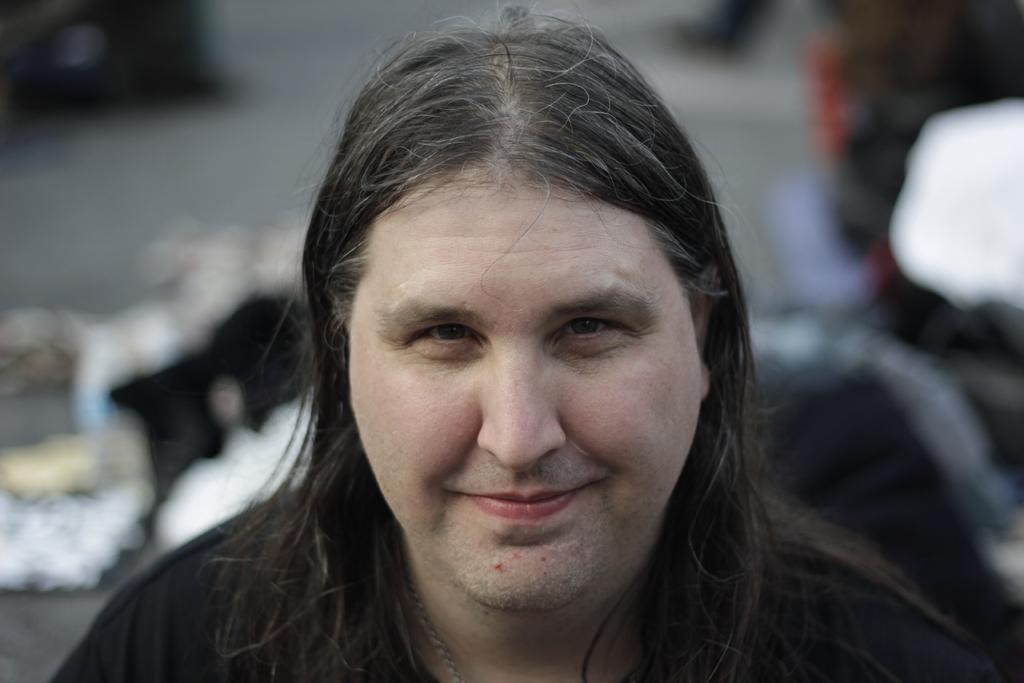In one or two sentences, can you explain what this image depicts? In this image we can see a man with long hair wearing black dress. 